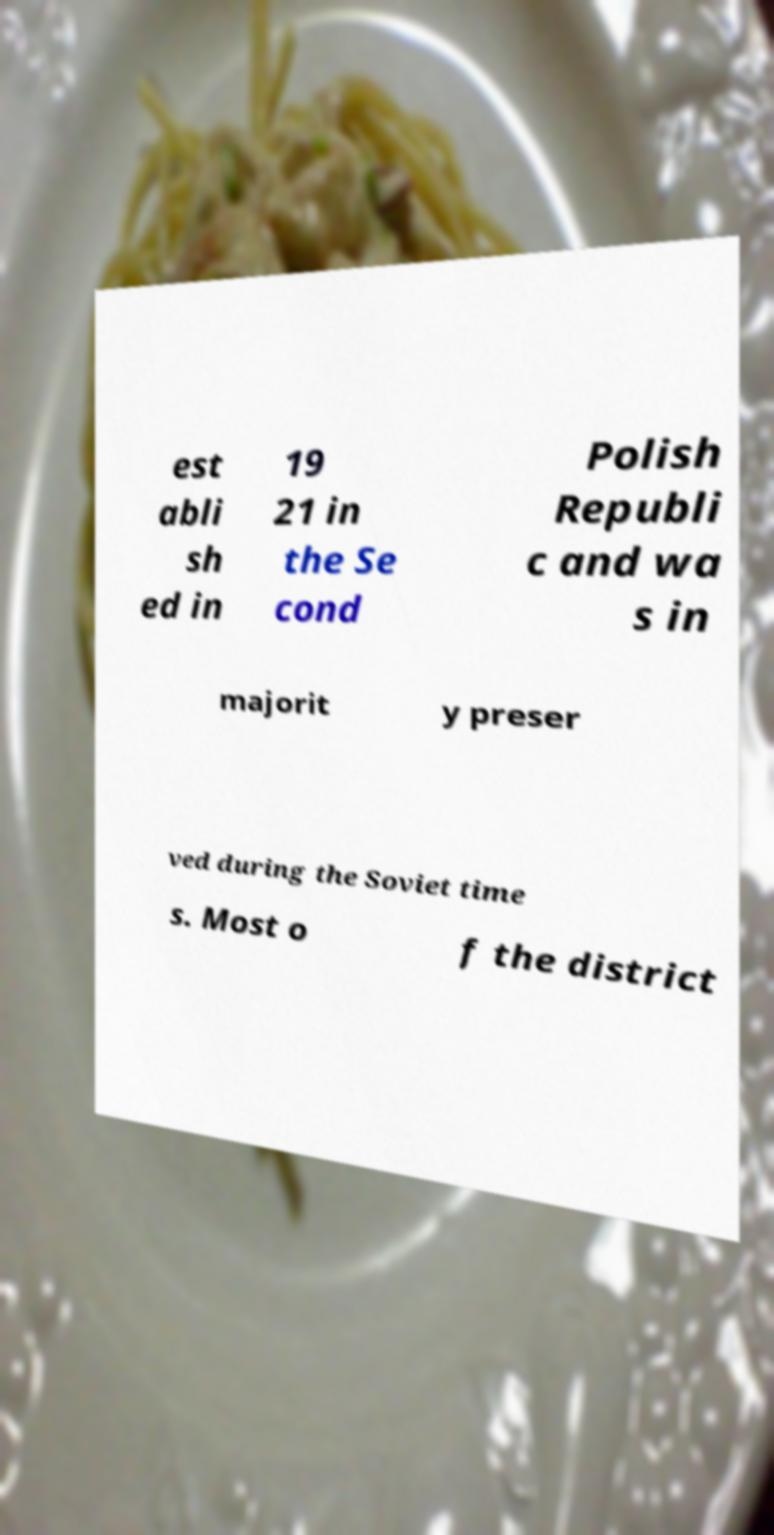Could you extract and type out the text from this image? est abli sh ed in 19 21 in the Se cond Polish Republi c and wa s in majorit y preser ved during the Soviet time s. Most o f the district 